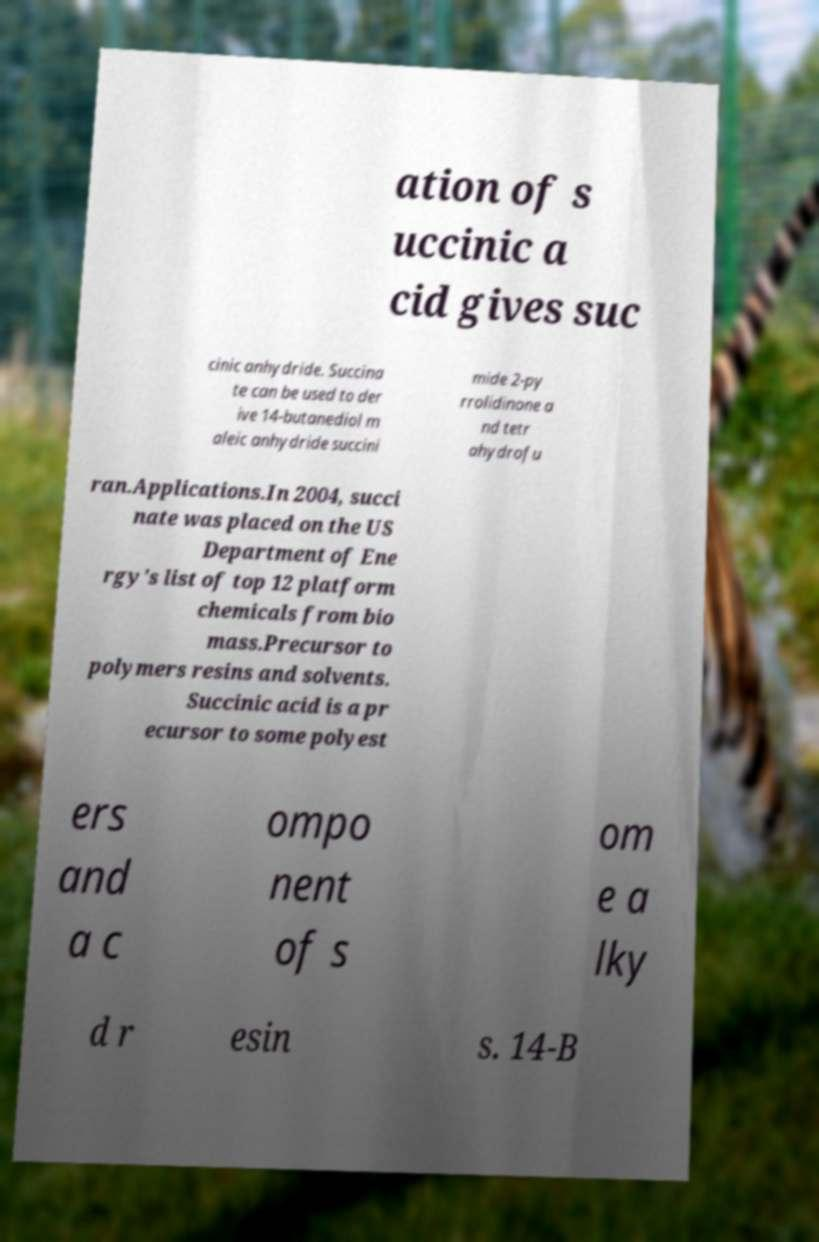Please read and relay the text visible in this image. What does it say? ation of s uccinic a cid gives suc cinic anhydride. Succina te can be used to der ive 14-butanediol m aleic anhydride succini mide 2-py rrolidinone a nd tetr ahydrofu ran.Applications.In 2004, succi nate was placed on the US Department of Ene rgy's list of top 12 platform chemicals from bio mass.Precursor to polymers resins and solvents. Succinic acid is a pr ecursor to some polyest ers and a c ompo nent of s om e a lky d r esin s. 14-B 